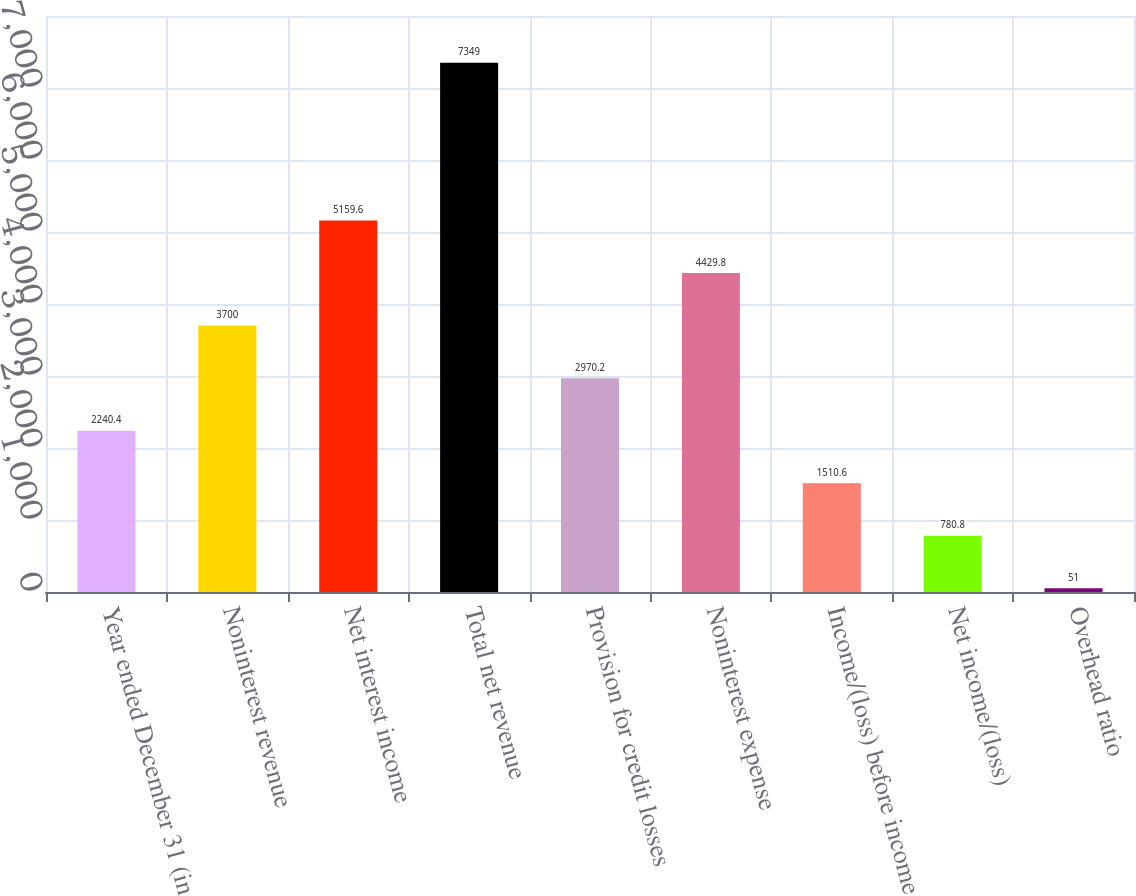Convert chart to OTSL. <chart><loc_0><loc_0><loc_500><loc_500><bar_chart><fcel>Year ended December 31 (in<fcel>Noninterest revenue<fcel>Net interest income<fcel>Total net revenue<fcel>Provision for credit losses<fcel>Noninterest expense<fcel>Income/(loss) before income<fcel>Net income/(loss)<fcel>Overhead ratio<nl><fcel>2240.4<fcel>3700<fcel>5159.6<fcel>7349<fcel>2970.2<fcel>4429.8<fcel>1510.6<fcel>780.8<fcel>51<nl></chart> 